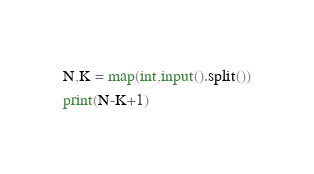<code> <loc_0><loc_0><loc_500><loc_500><_Python_>N,K = map(int,input().split())
print(N-K+1)</code> 